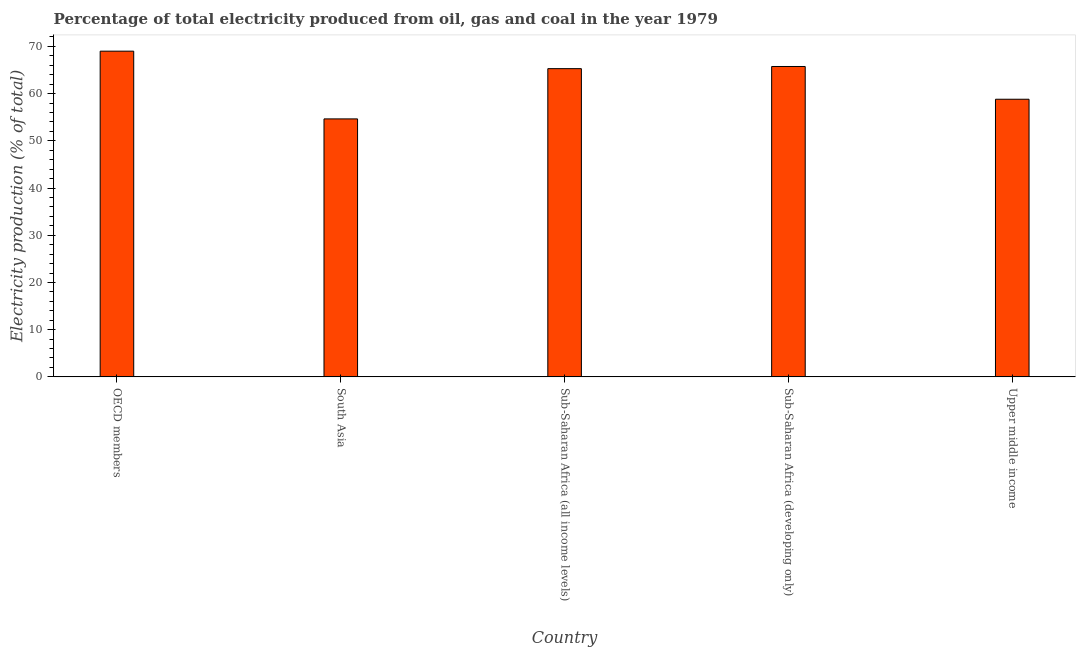Does the graph contain any zero values?
Your answer should be very brief. No. What is the title of the graph?
Provide a succinct answer. Percentage of total electricity produced from oil, gas and coal in the year 1979. What is the label or title of the Y-axis?
Offer a terse response. Electricity production (% of total). What is the electricity production in Upper middle income?
Your answer should be very brief. 58.81. Across all countries, what is the maximum electricity production?
Ensure brevity in your answer.  68.99. Across all countries, what is the minimum electricity production?
Give a very brief answer. 54.64. In which country was the electricity production minimum?
Keep it short and to the point. South Asia. What is the sum of the electricity production?
Offer a very short reply. 313.46. What is the difference between the electricity production in South Asia and Sub-Saharan Africa (developing only)?
Your response must be concise. -11.1. What is the average electricity production per country?
Provide a succinct answer. 62.69. What is the median electricity production?
Offer a terse response. 65.29. What is the ratio of the electricity production in OECD members to that in Sub-Saharan Africa (all income levels)?
Offer a terse response. 1.06. Is the electricity production in Sub-Saharan Africa (all income levels) less than that in Sub-Saharan Africa (developing only)?
Provide a succinct answer. Yes. What is the difference between the highest and the second highest electricity production?
Make the answer very short. 3.25. Is the sum of the electricity production in South Asia and Sub-Saharan Africa (all income levels) greater than the maximum electricity production across all countries?
Offer a terse response. Yes. What is the difference between the highest and the lowest electricity production?
Your answer should be compact. 14.35. Are all the bars in the graph horizontal?
Your answer should be compact. No. How many countries are there in the graph?
Offer a terse response. 5. What is the difference between two consecutive major ticks on the Y-axis?
Keep it short and to the point. 10. Are the values on the major ticks of Y-axis written in scientific E-notation?
Your answer should be compact. No. What is the Electricity production (% of total) in OECD members?
Your answer should be compact. 68.99. What is the Electricity production (% of total) in South Asia?
Offer a very short reply. 54.64. What is the Electricity production (% of total) in Sub-Saharan Africa (all income levels)?
Give a very brief answer. 65.29. What is the Electricity production (% of total) in Sub-Saharan Africa (developing only)?
Your answer should be compact. 65.74. What is the Electricity production (% of total) in Upper middle income?
Your answer should be compact. 58.81. What is the difference between the Electricity production (% of total) in OECD members and South Asia?
Your response must be concise. 14.35. What is the difference between the Electricity production (% of total) in OECD members and Sub-Saharan Africa (all income levels)?
Provide a succinct answer. 3.7. What is the difference between the Electricity production (% of total) in OECD members and Sub-Saharan Africa (developing only)?
Provide a short and direct response. 3.25. What is the difference between the Electricity production (% of total) in OECD members and Upper middle income?
Offer a very short reply. 10.18. What is the difference between the Electricity production (% of total) in South Asia and Sub-Saharan Africa (all income levels)?
Your response must be concise. -10.64. What is the difference between the Electricity production (% of total) in South Asia and Sub-Saharan Africa (developing only)?
Make the answer very short. -11.1. What is the difference between the Electricity production (% of total) in South Asia and Upper middle income?
Offer a very short reply. -4.16. What is the difference between the Electricity production (% of total) in Sub-Saharan Africa (all income levels) and Sub-Saharan Africa (developing only)?
Provide a short and direct response. -0.46. What is the difference between the Electricity production (% of total) in Sub-Saharan Africa (all income levels) and Upper middle income?
Your response must be concise. 6.48. What is the difference between the Electricity production (% of total) in Sub-Saharan Africa (developing only) and Upper middle income?
Make the answer very short. 6.94. What is the ratio of the Electricity production (% of total) in OECD members to that in South Asia?
Give a very brief answer. 1.26. What is the ratio of the Electricity production (% of total) in OECD members to that in Sub-Saharan Africa (all income levels)?
Give a very brief answer. 1.06. What is the ratio of the Electricity production (% of total) in OECD members to that in Sub-Saharan Africa (developing only)?
Your answer should be compact. 1.05. What is the ratio of the Electricity production (% of total) in OECD members to that in Upper middle income?
Provide a short and direct response. 1.17. What is the ratio of the Electricity production (% of total) in South Asia to that in Sub-Saharan Africa (all income levels)?
Provide a succinct answer. 0.84. What is the ratio of the Electricity production (% of total) in South Asia to that in Sub-Saharan Africa (developing only)?
Ensure brevity in your answer.  0.83. What is the ratio of the Electricity production (% of total) in South Asia to that in Upper middle income?
Make the answer very short. 0.93. What is the ratio of the Electricity production (% of total) in Sub-Saharan Africa (all income levels) to that in Upper middle income?
Keep it short and to the point. 1.11. What is the ratio of the Electricity production (% of total) in Sub-Saharan Africa (developing only) to that in Upper middle income?
Provide a succinct answer. 1.12. 